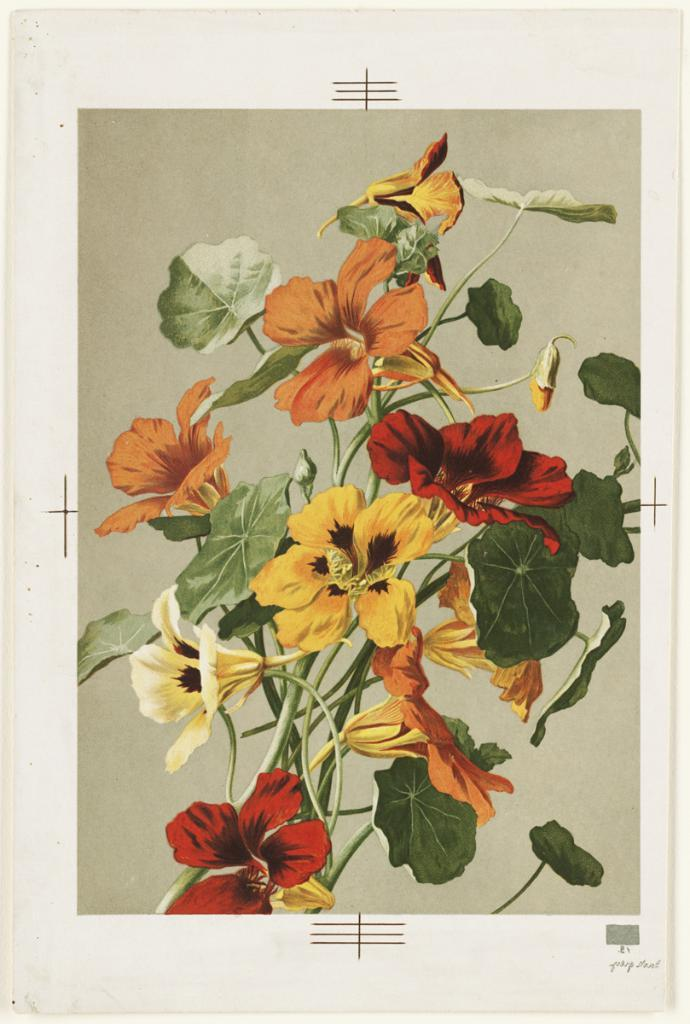What is depicted on the poster in the image? The poster contains flowers, stems, and leaves. Can you describe the elements of the poster in more detail? The poster contains flowers, which are depicted with stems and leaves. How many needles are attached to the wren in the image? There is no wren or needle present in the image; the poster contains flowers, stems, and leaves. 